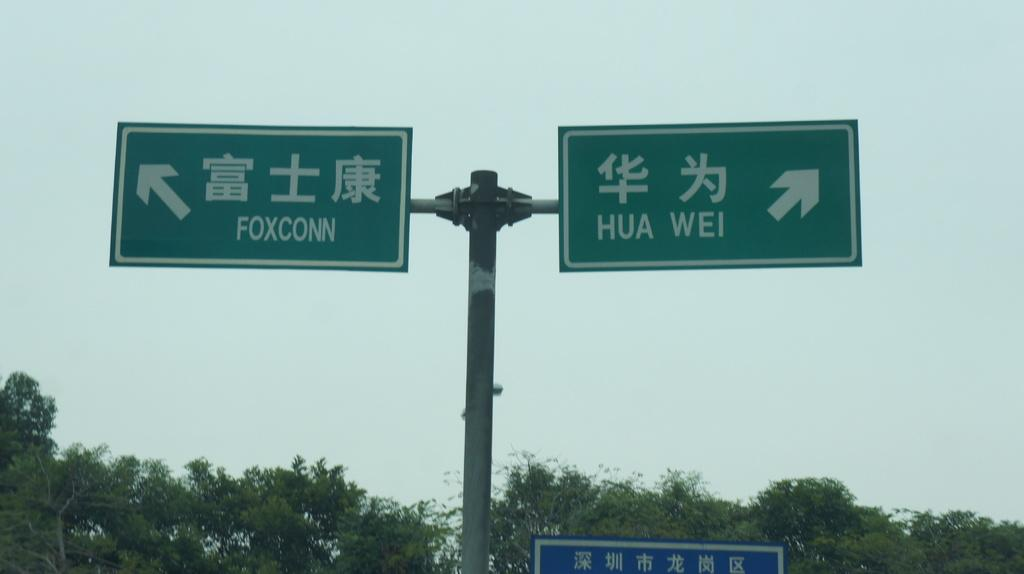<image>
Offer a succinct explanation of the picture presented. The road sign indicates that Foxconn is to the left and Hua Wei is to the right. 